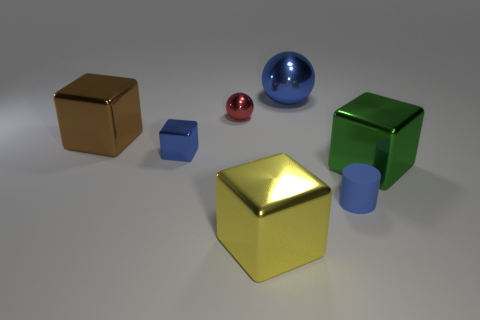Add 3 small cubes. How many objects exist? 10 Subtract all blocks. How many objects are left? 3 Subtract all small purple rubber blocks. Subtract all big things. How many objects are left? 3 Add 4 rubber cylinders. How many rubber cylinders are left? 5 Add 5 red matte things. How many red matte things exist? 5 Subtract 1 green cubes. How many objects are left? 6 